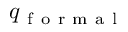<formula> <loc_0><loc_0><loc_500><loc_500>q _ { f o r m a l }</formula> 